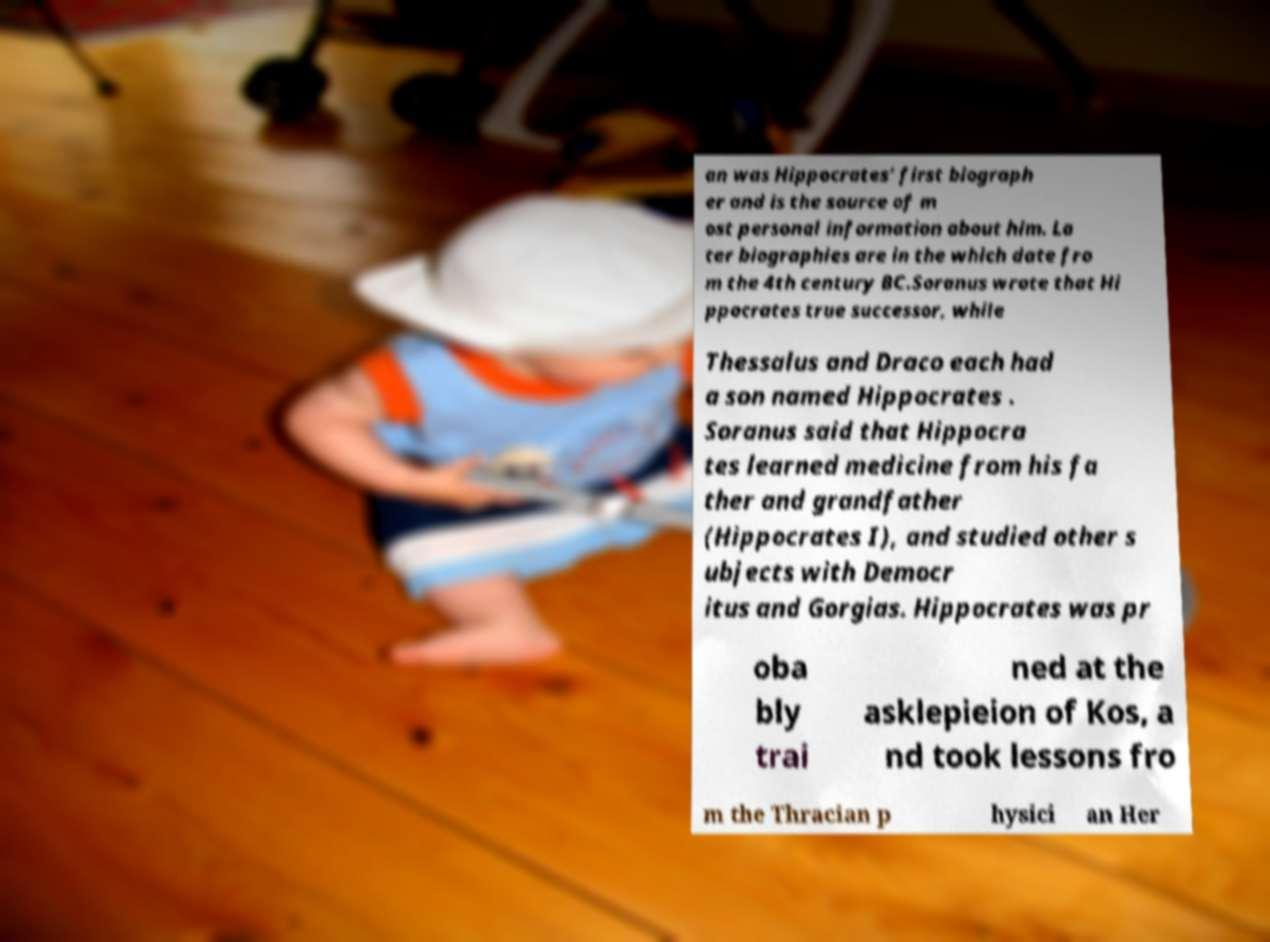For documentation purposes, I need the text within this image transcribed. Could you provide that? an was Hippocrates' first biograph er and is the source of m ost personal information about him. La ter biographies are in the which date fro m the 4th century BC.Soranus wrote that Hi ppocrates true successor, while Thessalus and Draco each had a son named Hippocrates . Soranus said that Hippocra tes learned medicine from his fa ther and grandfather (Hippocrates I), and studied other s ubjects with Democr itus and Gorgias. Hippocrates was pr oba bly trai ned at the asklepieion of Kos, a nd took lessons fro m the Thracian p hysici an Her 